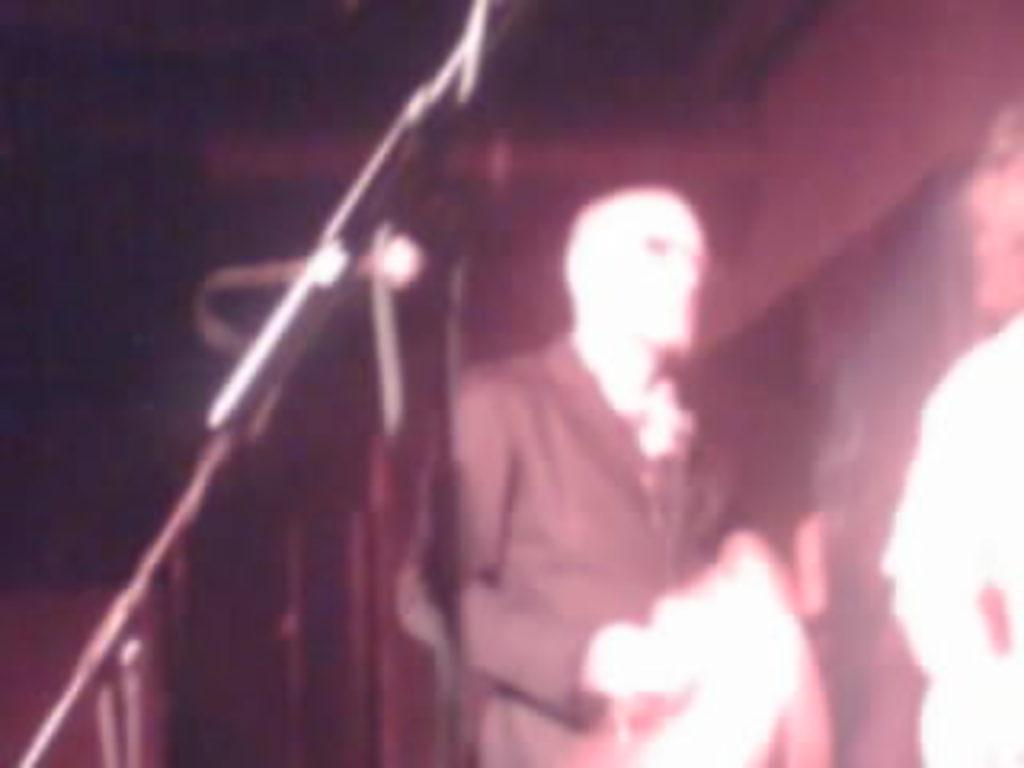How many people are present in the image? There are two people in the image. What are the people doing in the image? The people are standing. What can be seen in the background of the image? There is a wall in the background of the image. What type of grass can be seen growing on the wrist of the person on the left? There is no grass present in the image, and the wrist of the person on the left is not visible. 